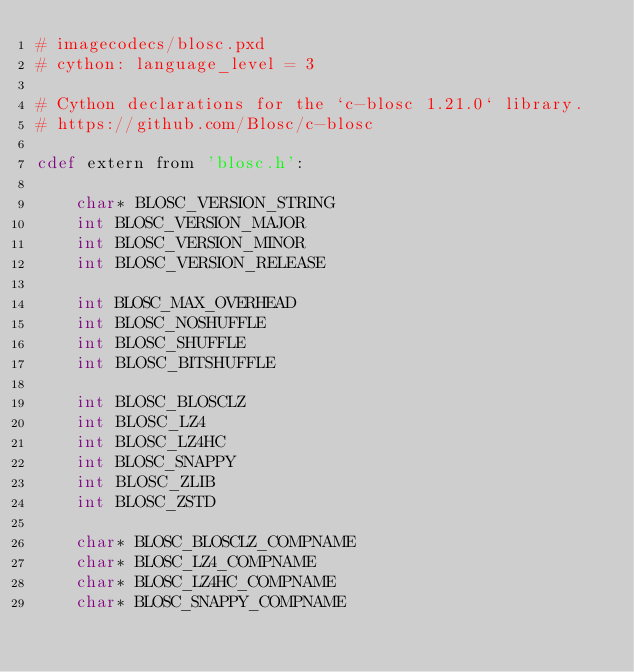Convert code to text. <code><loc_0><loc_0><loc_500><loc_500><_Cython_># imagecodecs/blosc.pxd
# cython: language_level = 3

# Cython declarations for the `c-blosc 1.21.0` library.
# https://github.com/Blosc/c-blosc

cdef extern from 'blosc.h':

    char* BLOSC_VERSION_STRING
    int BLOSC_VERSION_MAJOR
    int BLOSC_VERSION_MINOR
    int BLOSC_VERSION_RELEASE

    int BLOSC_MAX_OVERHEAD
    int BLOSC_NOSHUFFLE
    int BLOSC_SHUFFLE
    int BLOSC_BITSHUFFLE

    int BLOSC_BLOSCLZ
    int BLOSC_LZ4
    int BLOSC_LZ4HC
    int BLOSC_SNAPPY
    int BLOSC_ZLIB
    int BLOSC_ZSTD

    char* BLOSC_BLOSCLZ_COMPNAME
    char* BLOSC_LZ4_COMPNAME
    char* BLOSC_LZ4HC_COMPNAME
    char* BLOSC_SNAPPY_COMPNAME</code> 